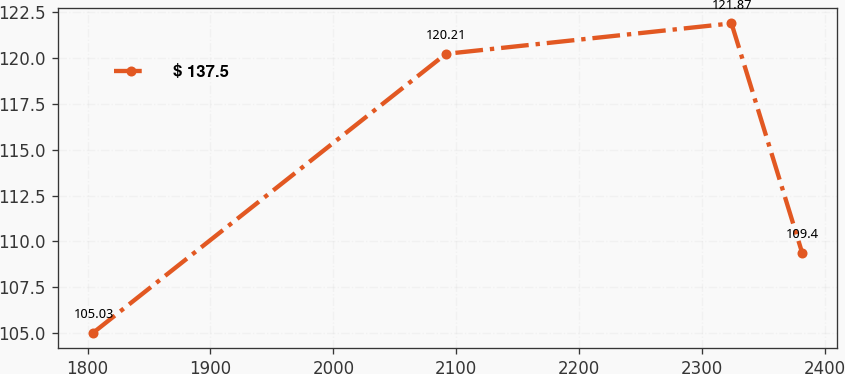Convert chart. <chart><loc_0><loc_0><loc_500><loc_500><line_chart><ecel><fcel>$ 137.5<nl><fcel>1804.49<fcel>105.03<nl><fcel>2091.59<fcel>120.21<nl><fcel>2324.05<fcel>121.87<nl><fcel>2381.47<fcel>109.4<nl></chart> 